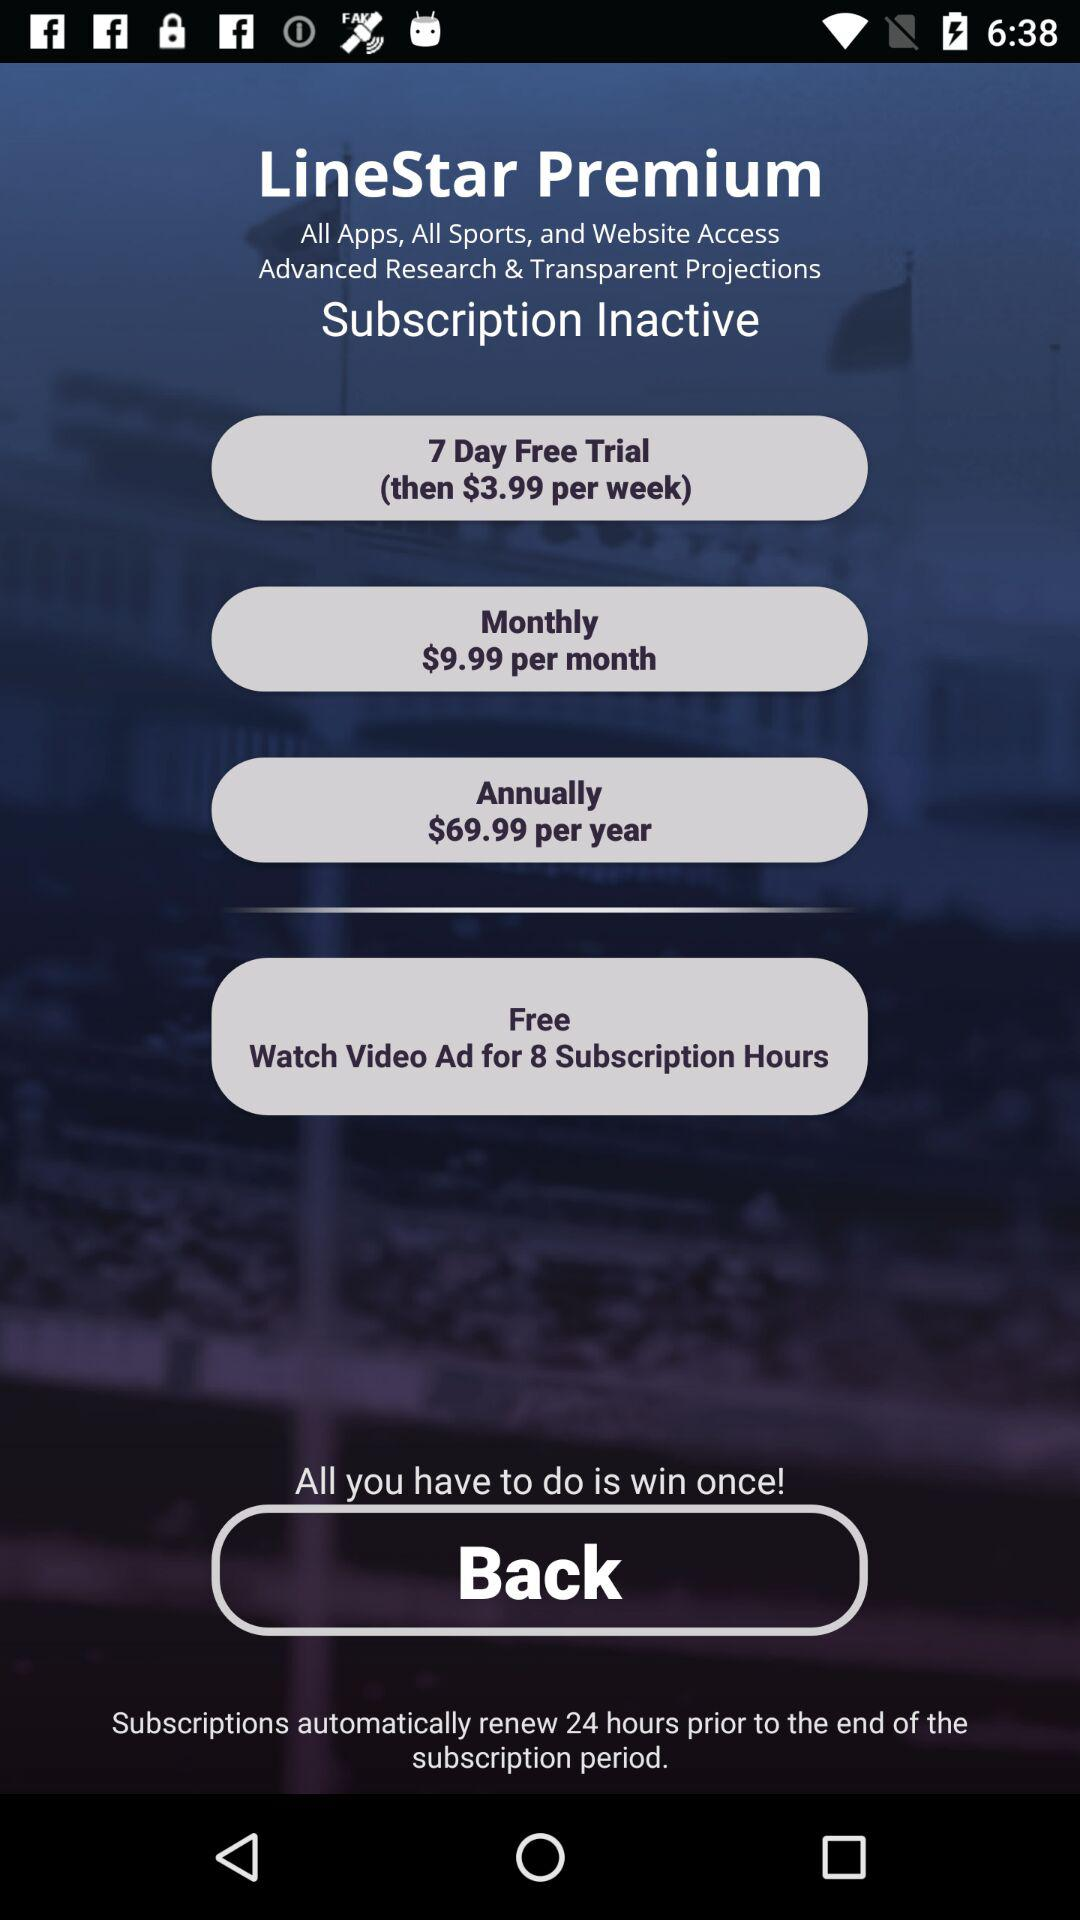For how many days is the free trial? The free trial is for 7 days. 